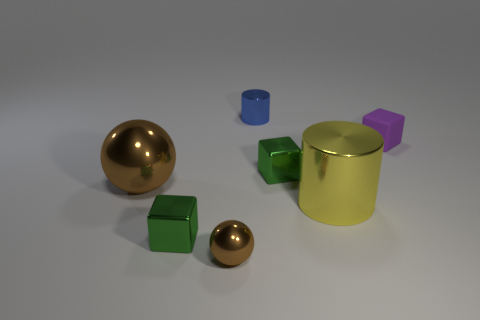Do the purple object and the blue cylinder have the same size?
Keep it short and to the point. Yes. How many cubes are both to the right of the tiny blue thing and in front of the purple matte thing?
Make the answer very short. 1. How many red objects are either matte blocks or big cylinders?
Your answer should be very brief. 0. What number of metal objects are blue things or green objects?
Provide a short and direct response. 3. Are any large red objects visible?
Ensure brevity in your answer.  No. Is the big yellow thing the same shape as the large brown object?
Your response must be concise. No. How many brown things are in front of the yellow cylinder that is right of the small block in front of the big shiny ball?
Provide a short and direct response. 1. There is a block that is both in front of the matte thing and right of the small metallic cylinder; what material is it?
Provide a short and direct response. Metal. The cube that is on the left side of the small purple rubber cube and to the right of the blue metal cylinder is what color?
Provide a succinct answer. Green. Is there anything else that has the same color as the small metallic ball?
Make the answer very short. Yes. 